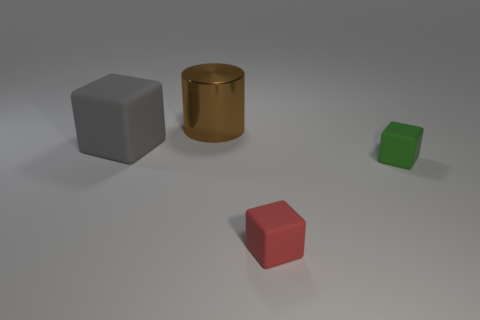Subtract all green rubber blocks. How many blocks are left? 2 Add 1 small purple cylinders. How many objects exist? 5 Subtract all gray cubes. How many cubes are left? 2 Subtract all cylinders. How many objects are left? 3 Subtract all yellow blocks. Subtract all yellow spheres. How many blocks are left? 3 Add 3 tiny red objects. How many tiny red objects exist? 4 Subtract 0 cyan balls. How many objects are left? 4 Subtract all brown cylinders. Subtract all green things. How many objects are left? 2 Add 4 cylinders. How many cylinders are left? 5 